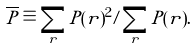Convert formula to latex. <formula><loc_0><loc_0><loc_500><loc_500>\overline { P } \equiv \sum _ { r } P ( r ) ^ { 2 } / \sum _ { r } P ( r ) .</formula> 